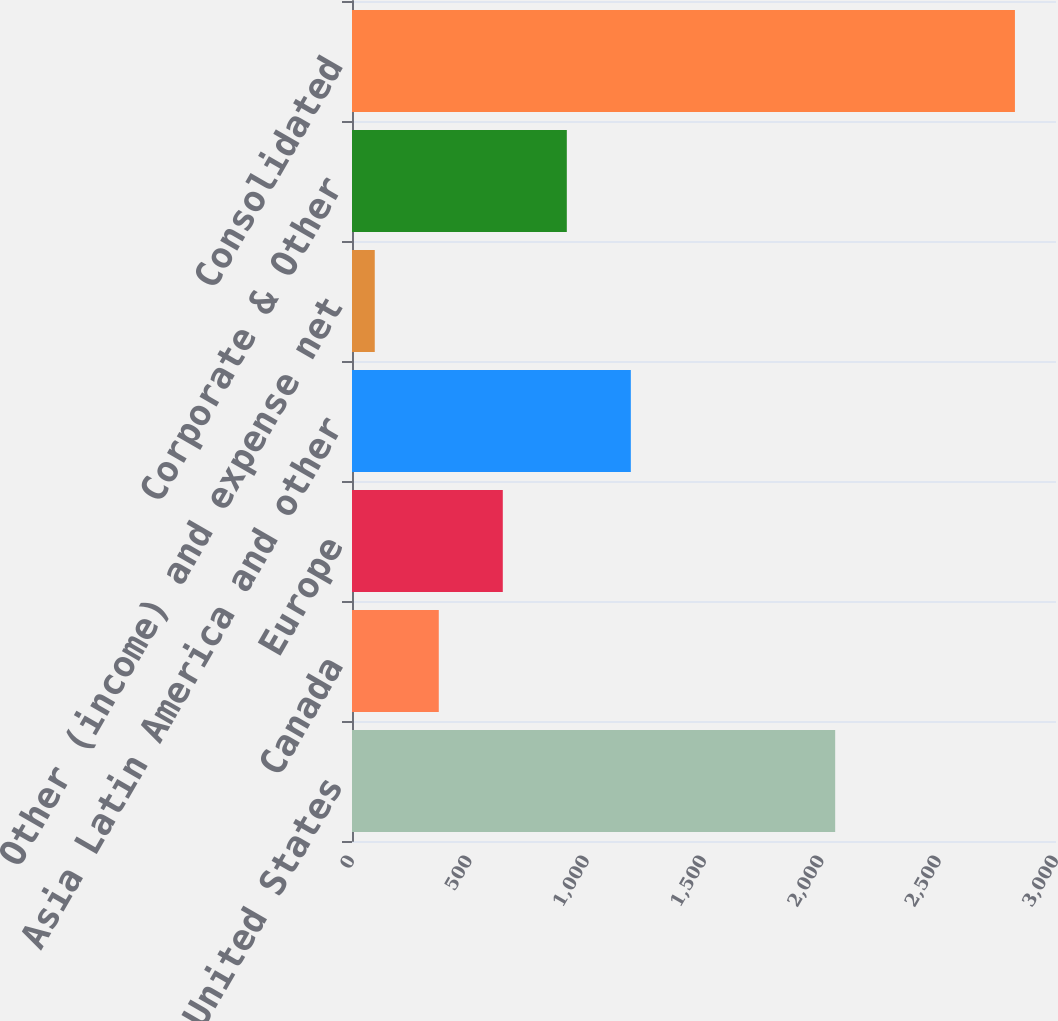Convert chart. <chart><loc_0><loc_0><loc_500><loc_500><bar_chart><fcel>United States<fcel>Canada<fcel>Europe<fcel>Asia Latin America and other<fcel>Other (income) and expense net<fcel>Corporate & Other<fcel>Consolidated<nl><fcel>2059<fcel>369.8<fcel>642.6<fcel>1188.2<fcel>97<fcel>915.4<fcel>2825<nl></chart> 